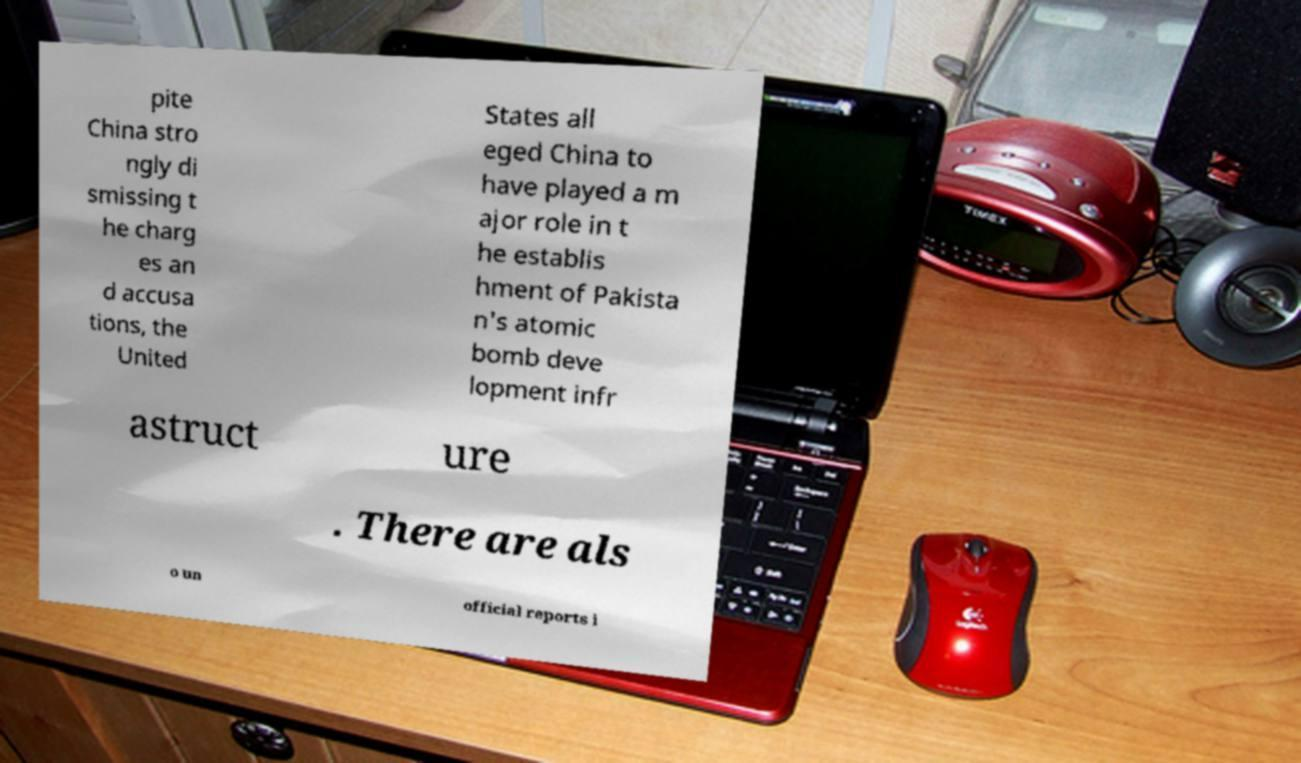For documentation purposes, I need the text within this image transcribed. Could you provide that? pite China stro ngly di smissing t he charg es an d accusa tions, the United States all eged China to have played a m ajor role in t he establis hment of Pakista n's atomic bomb deve lopment infr astruct ure . There are als o un official reports i 